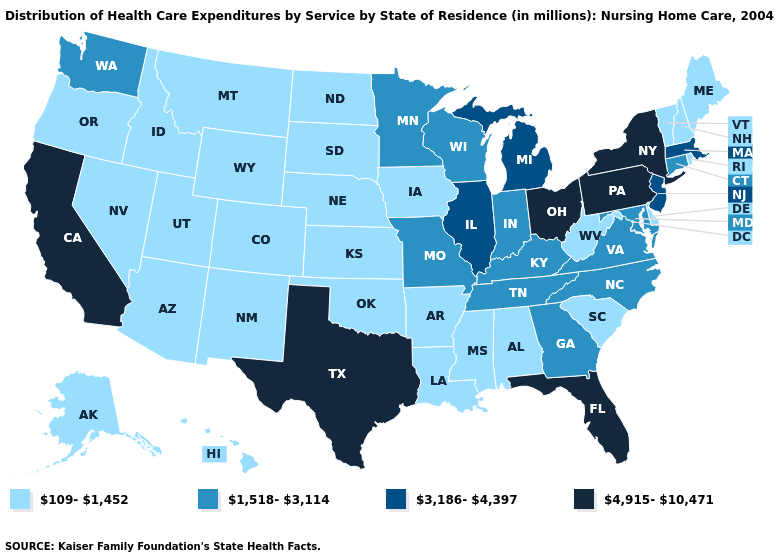What is the value of Alaska?
Quick response, please. 109-1,452. What is the value of Hawaii?
Write a very short answer. 109-1,452. Is the legend a continuous bar?
Short answer required. No. What is the value of Texas?
Quick response, please. 4,915-10,471. Does Pennsylvania have the highest value in the Northeast?
Answer briefly. Yes. What is the highest value in the USA?
Be succinct. 4,915-10,471. Does the map have missing data?
Answer briefly. No. What is the value of New Hampshire?
Keep it brief. 109-1,452. Name the states that have a value in the range 4,915-10,471?
Concise answer only. California, Florida, New York, Ohio, Pennsylvania, Texas. Name the states that have a value in the range 4,915-10,471?
Answer briefly. California, Florida, New York, Ohio, Pennsylvania, Texas. Among the states that border Alabama , which have the highest value?
Write a very short answer. Florida. Does Wisconsin have the highest value in the USA?
Answer briefly. No. 